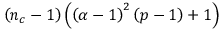Convert formula to latex. <formula><loc_0><loc_0><loc_500><loc_500>\left ( n _ { c } - 1 \right ) \left ( \left ( \alpha - 1 \right ) ^ { 2 } \left ( p - 1 \right ) + 1 \right )</formula> 